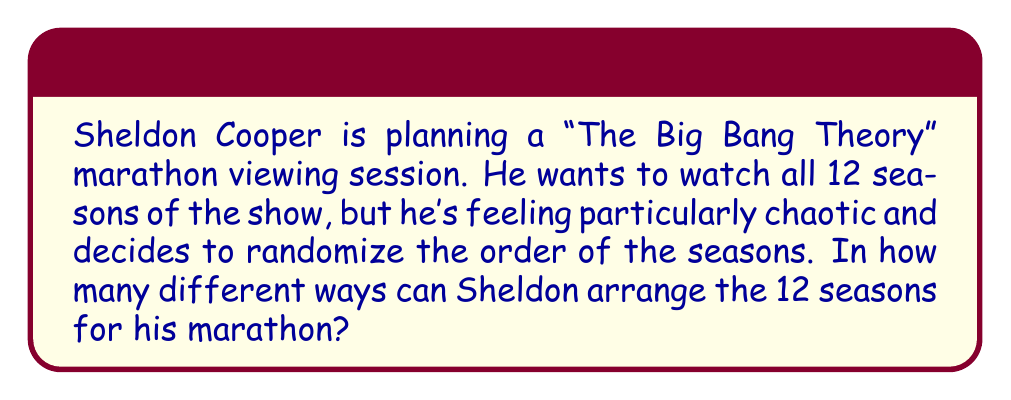Give your solution to this math problem. To solve this problem, we need to use the concept of permutations. Since Sheldon is arranging all 12 seasons without repetition and the order matters, this is a straightforward permutation problem.

The number of permutations of n distinct objects is given by:

$$ P(n) = n! $$

Where $n!$ represents the factorial of n.

In this case, we have 12 seasons to arrange, so:

$$ n = 12 $$

Therefore, the number of ways to arrange the 12 seasons is:

$$ P(12) = 12! $$

Calculating this out:

$$ 12! = 12 \times 11 \times 10 \times 9 \times 8 \times 7 \times 6 \times 5 \times 4 \times 3 \times 2 \times 1 $$

$$ = 479,001,600 $$

This means Sheldon has 479,001,600 different ways to arrange the order of the seasons for his marathon viewing session.
Answer: $479,001,600$ 